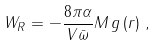Convert formula to latex. <formula><loc_0><loc_0><loc_500><loc_500>W _ { R } = - \frac { 8 \pi \alpha } { V \bar { \omega } } M \, g \left ( r \right ) \, ,</formula> 